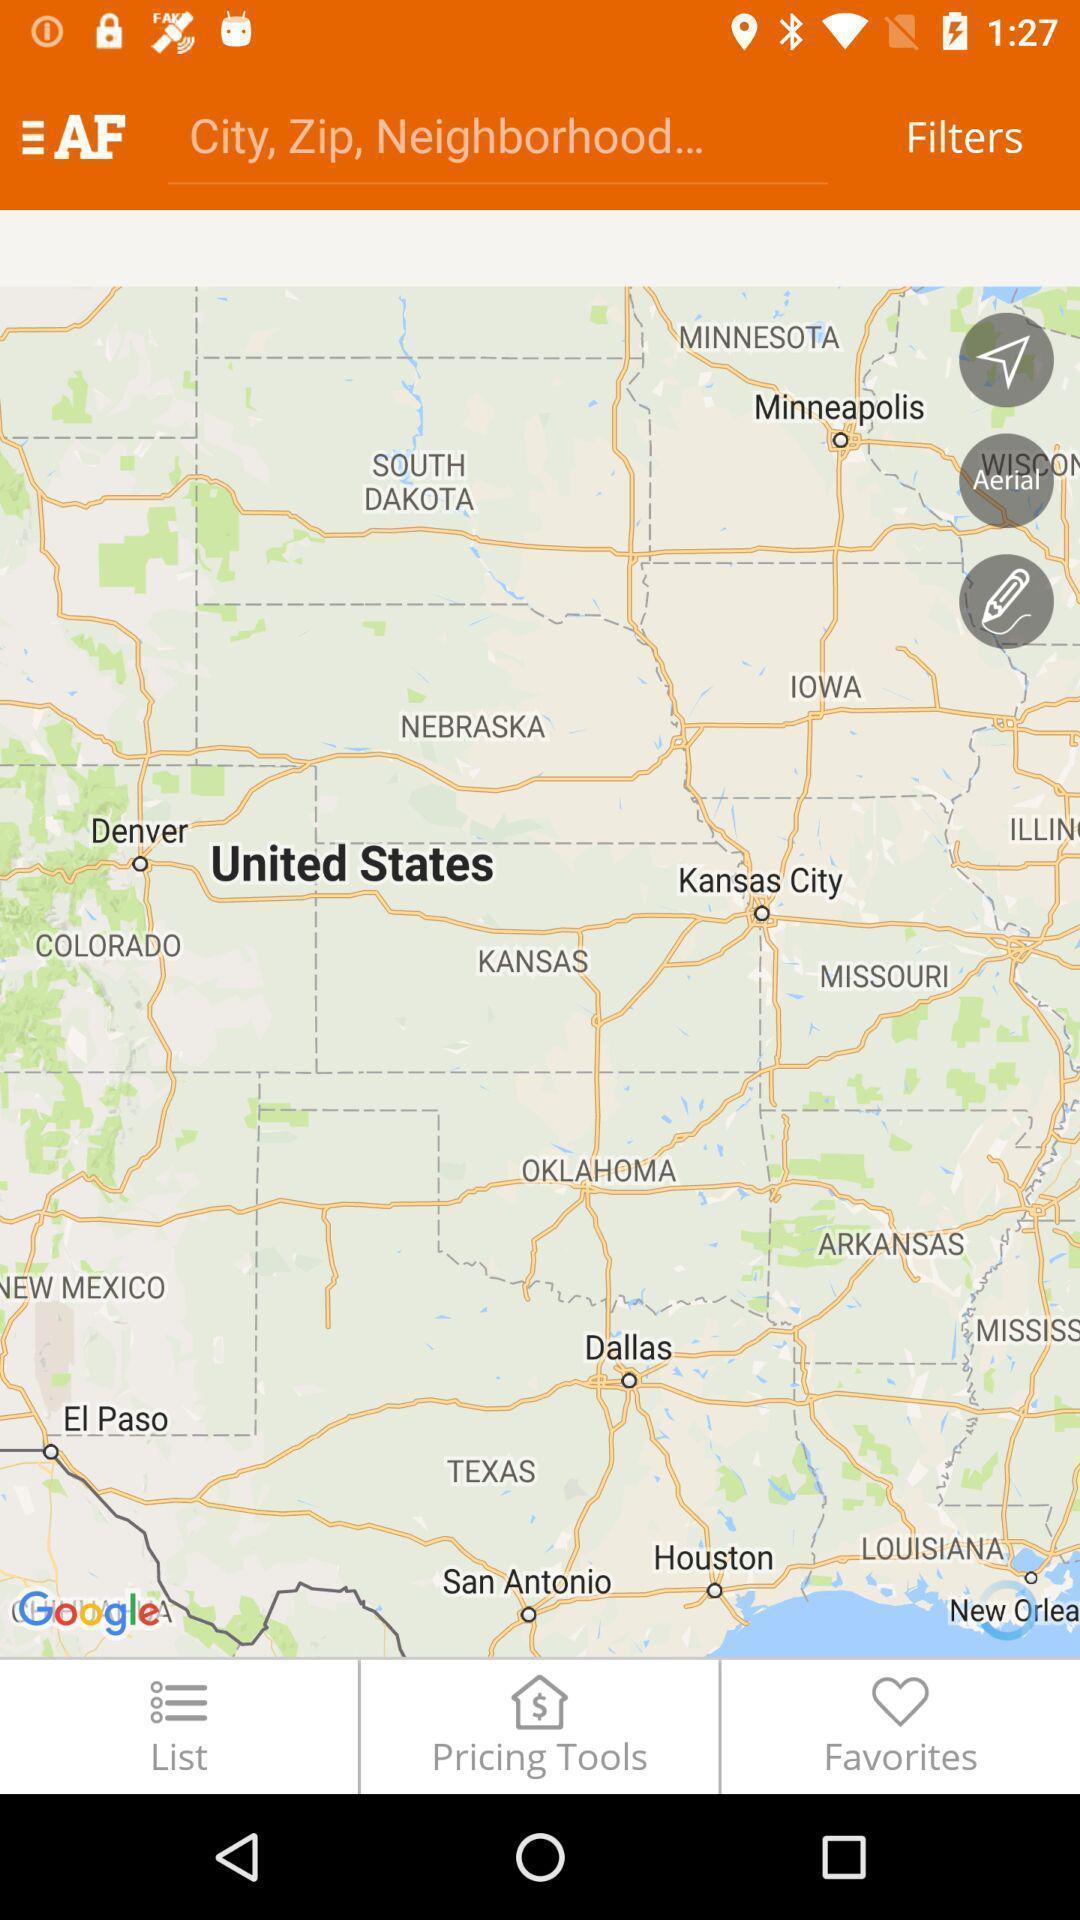Give me a summary of this screen capture. Screen shows different locations on a map. 